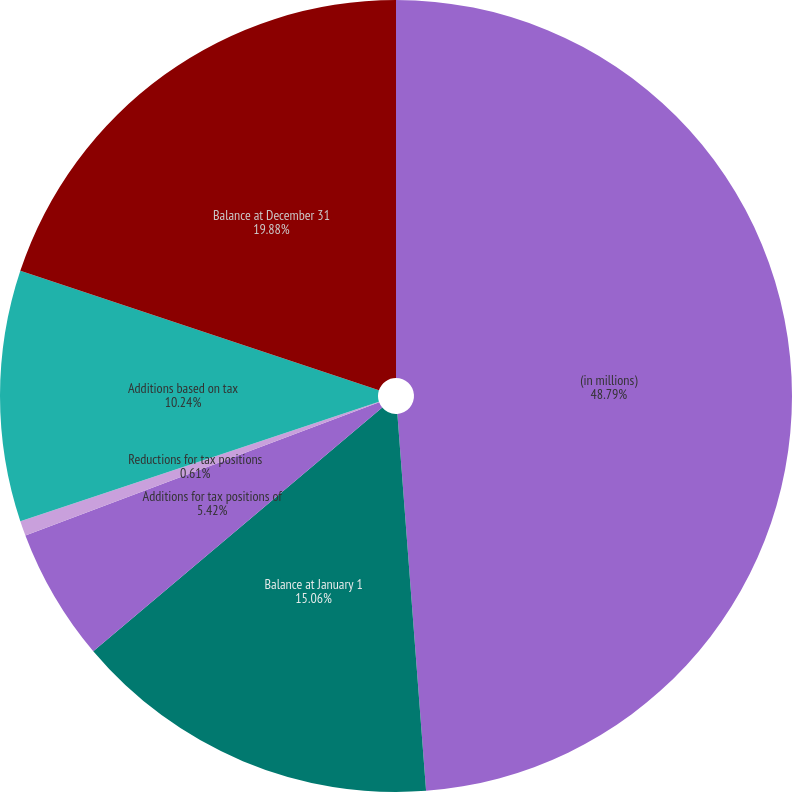Convert chart. <chart><loc_0><loc_0><loc_500><loc_500><pie_chart><fcel>(in millions)<fcel>Balance at January 1<fcel>Additions for tax positions of<fcel>Reductions for tax positions<fcel>Additions based on tax<fcel>Balance at December 31<nl><fcel>48.79%<fcel>15.06%<fcel>5.42%<fcel>0.61%<fcel>10.24%<fcel>19.88%<nl></chart> 